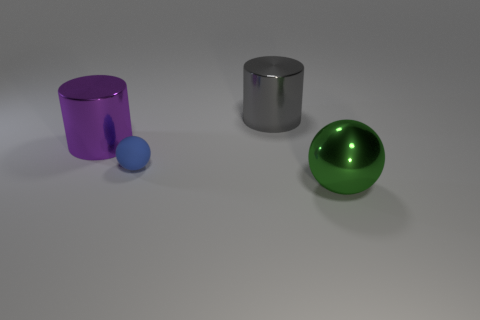What size is the blue sphere right of the large metallic cylinder that is left of the ball behind the green object?
Offer a very short reply. Small. How many things are either metallic cylinders on the right side of the purple cylinder or gray cylinders that are behind the big purple thing?
Provide a succinct answer. 1. What is the shape of the green shiny thing?
Keep it short and to the point. Sphere. How many other things are made of the same material as the tiny blue thing?
Keep it short and to the point. 0. What size is the blue object that is the same shape as the big green metallic object?
Your answer should be compact. Small. There is a big cylinder behind the shiny cylinder that is in front of the cylinder behind the purple shiny thing; what is it made of?
Your answer should be very brief. Metal. Are any big cyan metallic objects visible?
Your response must be concise. No. What is the color of the matte sphere?
Your answer should be very brief. Blue. What is the color of the other big thing that is the same shape as the gray shiny object?
Offer a very short reply. Purple. Do the matte thing and the large green shiny thing have the same shape?
Your answer should be compact. Yes. 